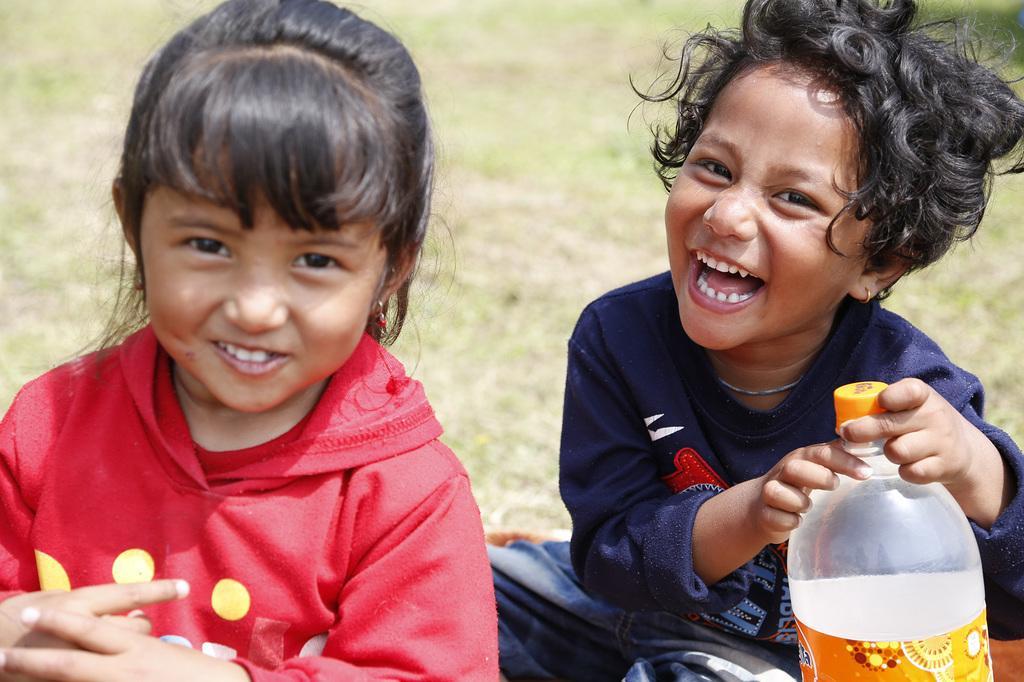Describe this image in one or two sentences. In this picture there are two girls sitting on the ground. One of the girl is holding a water bottle in her hand. Both of them were smiling. In the background there is a land. 